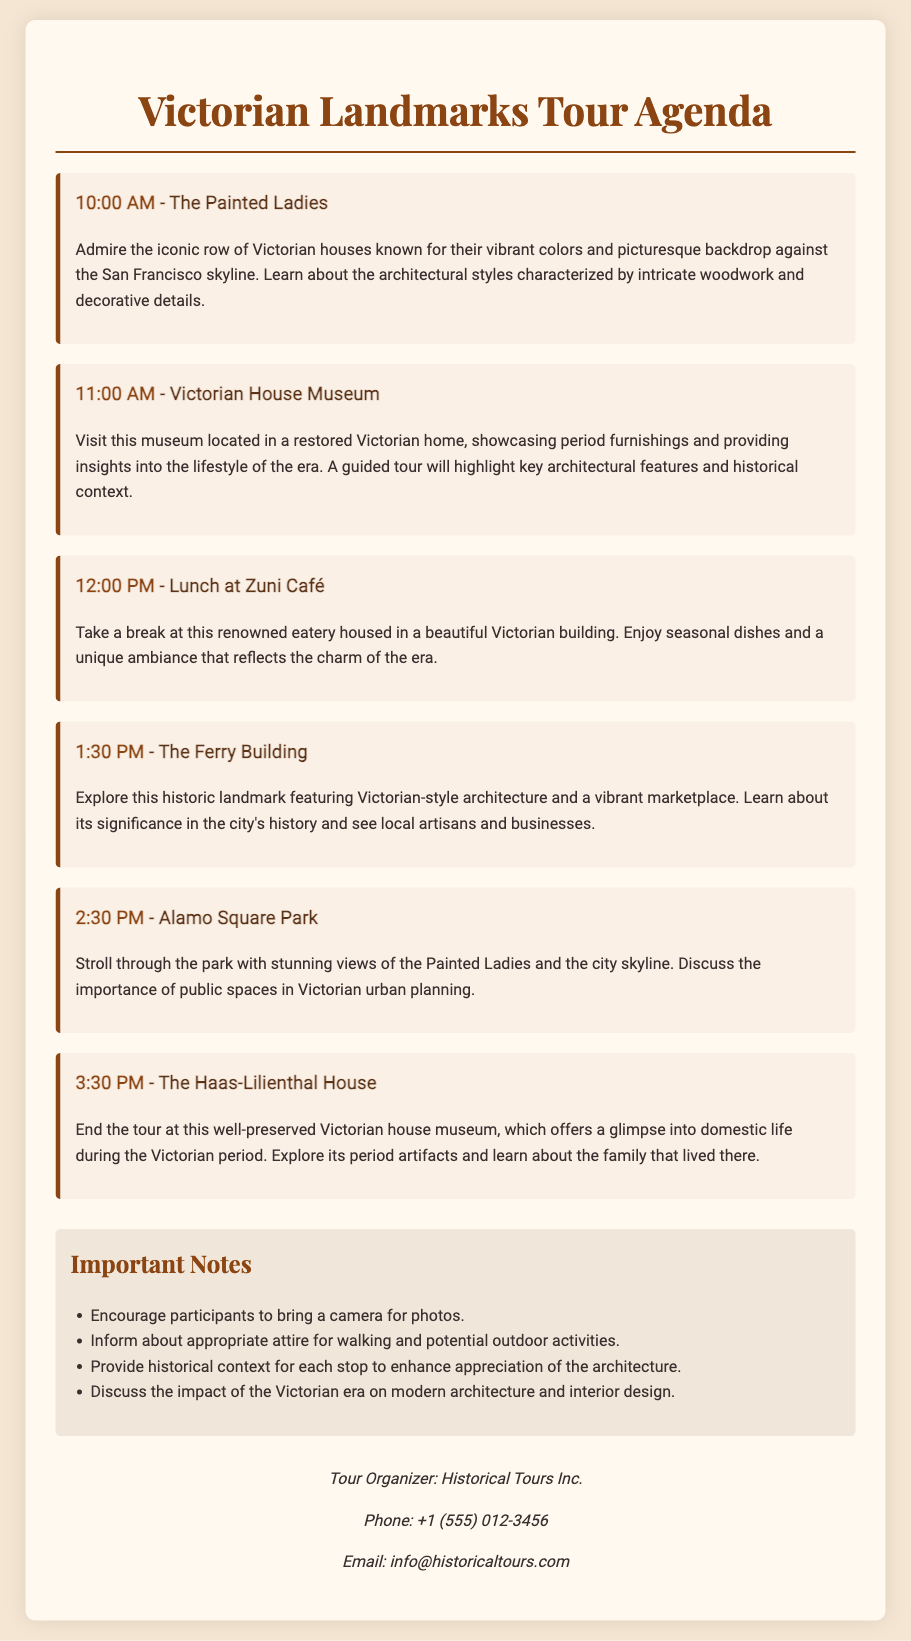what time does the tour start? The tour starts at 10:00 AM, as indicated at the beginning of the agenda.
Answer: 10:00 AM where will the lunch break be? The lunch break will be at Zuni Café, which is mentioned in the agenda.
Answer: Zuni Café how many stops are there in the tour? The agenda lists a total of six stops, including the Painted Ladies and Haas-Lilienthal House.
Answer: six what is a key focus during the visit to The Ferry Building? The focus during the visit to The Ferry Building is on its historical significance and the marketplace.
Answer: historical significance what is one of the important notes for participants? The document lists several notes, one of which is to encourage participants to bring a camera for photos.
Answer: bring a camera how long is the lunch break scheduled for? The lunch break is scheduled from 12:00 PM to 1:30 PM, giving 1.5 hours for lunch.
Answer: 1.5 hours what architectural style is associated with the Painted Ladies? The Painted Ladies are known for their Victorian architectural style featuring intricate woodwork and decorative details.
Answer: Victorian who is the tour organizer? The tour organizer is Historical Tours Inc., as specified in the contact information section.
Answer: Historical Tours Inc 